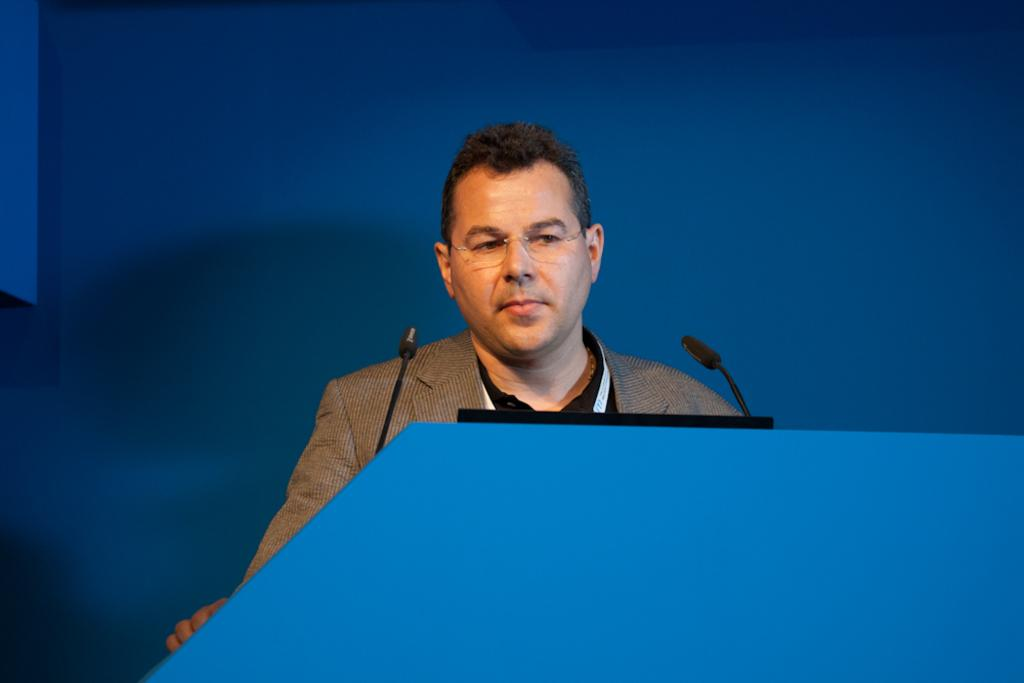What is the man in the image wearing? The man is wearing a suit and spectacles. What can be seen on the podium in the image? There is a laptop and two microphones on the podium. What is the color of the background in the image? The background of the image appears blue in color. Can you see any fish swimming in the background of the image? No, there are no fish visible in the image. The background appears to be a blue color, but it does not depict any aquatic life. 